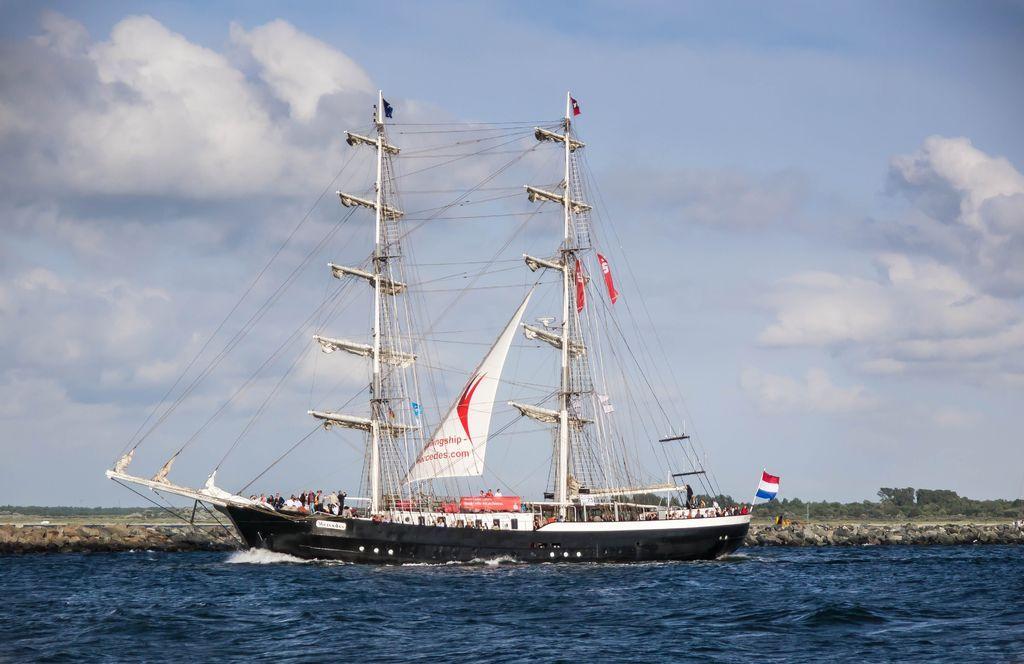Could you give a brief overview of what you see in this image? In this image we can see a ship on the water. Here we can see a flag, poles, trees, and people. In the background there is sky with clouds. 